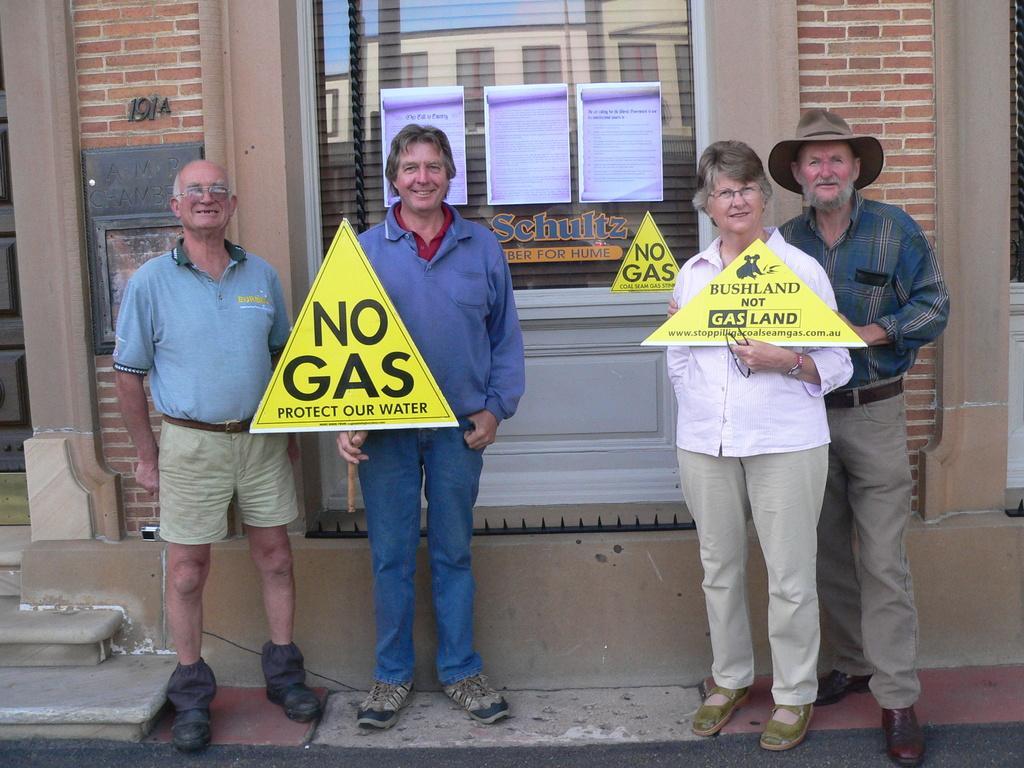Can you describe this image briefly? In this image, we can see persons wearing clothes and standing in front of the wall. There are two persons in the middle of the image holding boards with their hands. There is a window at the top of the image. 